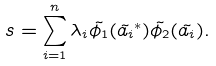Convert formula to latex. <formula><loc_0><loc_0><loc_500><loc_500>s = \sum _ { i = 1 } ^ { n } \lambda _ { i } \tilde { \phi _ { 1 } } ( \tilde { a _ { i } } ^ { * } ) \tilde { \phi _ { 2 } } ( \tilde { a _ { i } } ) .</formula> 